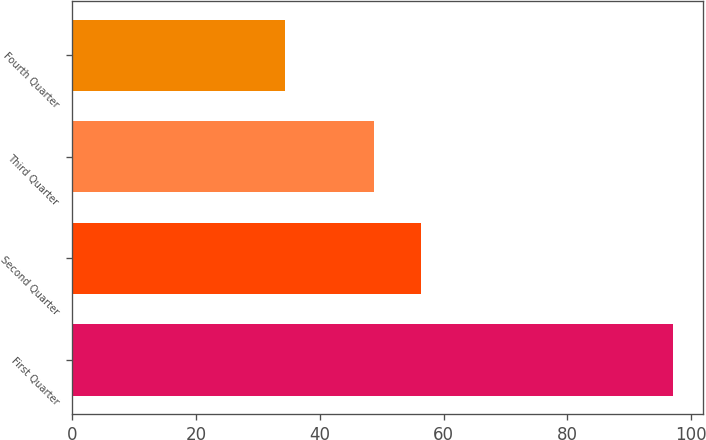<chart> <loc_0><loc_0><loc_500><loc_500><bar_chart><fcel>First Quarter<fcel>Second Quarter<fcel>Third Quarter<fcel>Fourth Quarter<nl><fcel>97<fcel>56.41<fcel>48.7<fcel>34.34<nl></chart> 